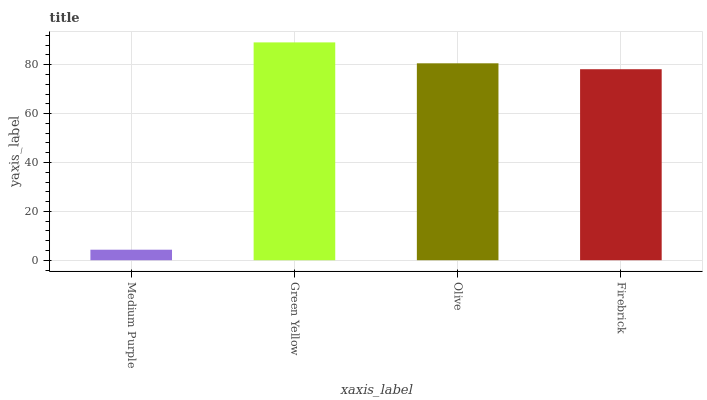Is Medium Purple the minimum?
Answer yes or no. Yes. Is Green Yellow the maximum?
Answer yes or no. Yes. Is Olive the minimum?
Answer yes or no. No. Is Olive the maximum?
Answer yes or no. No. Is Green Yellow greater than Olive?
Answer yes or no. Yes. Is Olive less than Green Yellow?
Answer yes or no. Yes. Is Olive greater than Green Yellow?
Answer yes or no. No. Is Green Yellow less than Olive?
Answer yes or no. No. Is Olive the high median?
Answer yes or no. Yes. Is Firebrick the low median?
Answer yes or no. Yes. Is Medium Purple the high median?
Answer yes or no. No. Is Olive the low median?
Answer yes or no. No. 